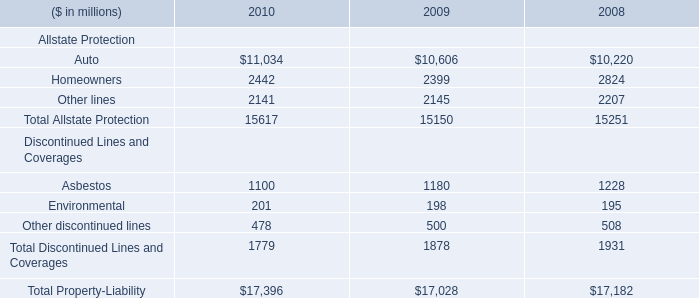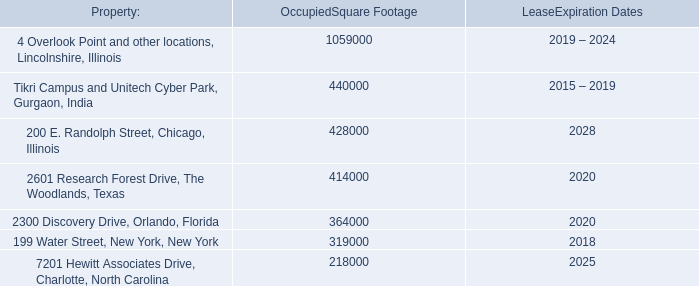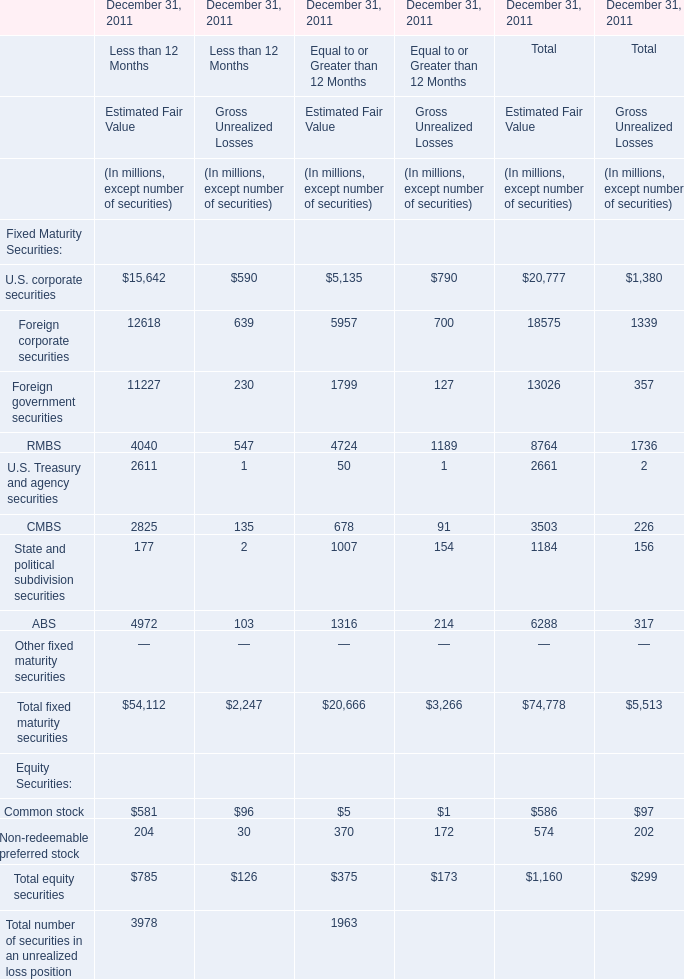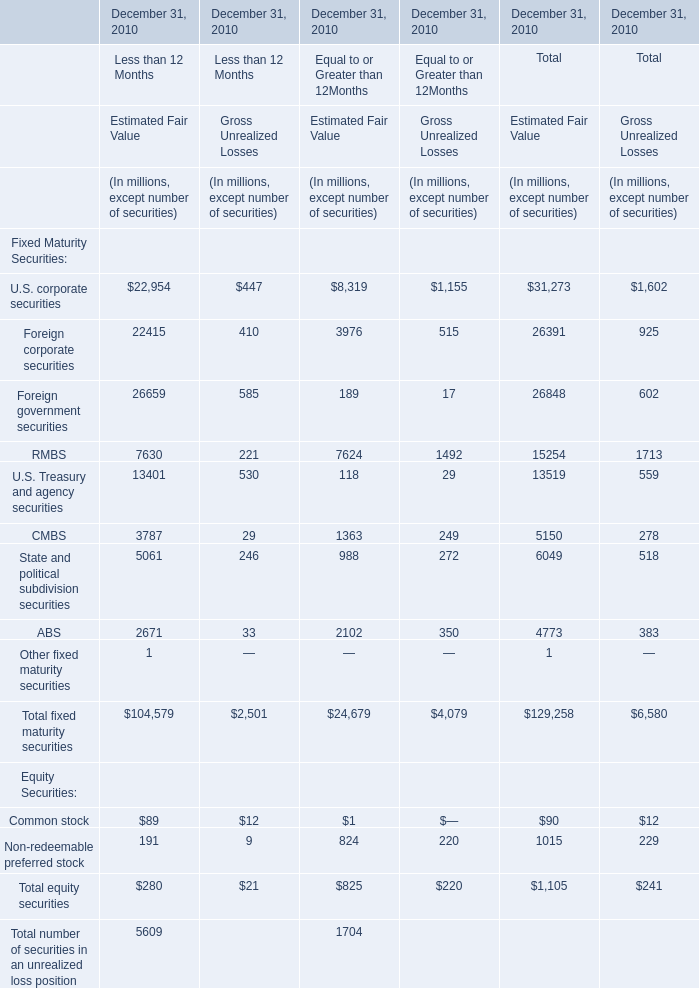What is the sum of CMBS, State and political subdivision securities and ABS in 2011 for Estimated Fair Value? (in million) 
Computations: ((3503 + 1184) + 6288)
Answer: 10975.0. 